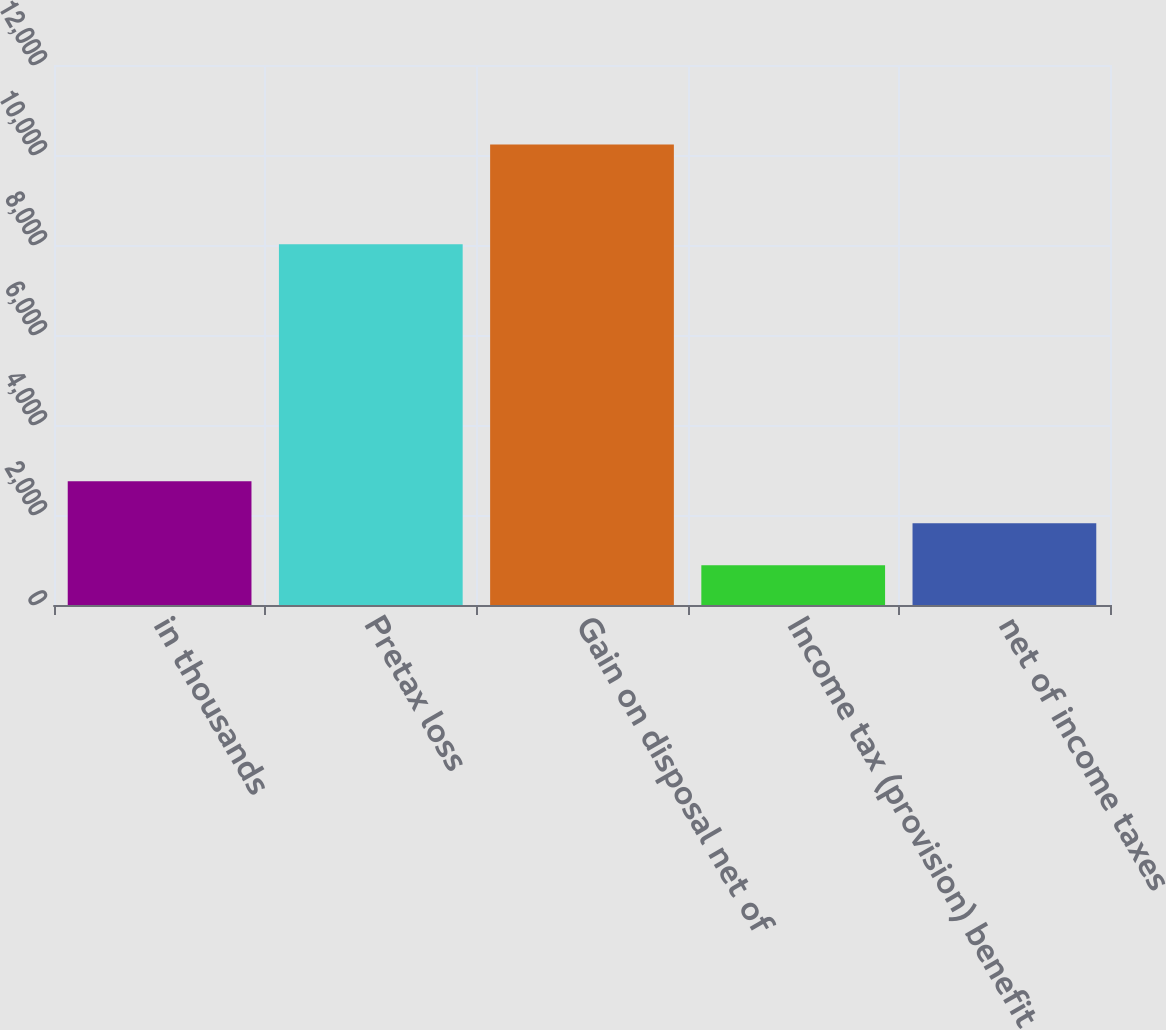Convert chart to OTSL. <chart><loc_0><loc_0><loc_500><loc_500><bar_chart><fcel>in thousands<fcel>Pretax loss<fcel>Gain on disposal net of<fcel>Income tax (provision) benefit<fcel>net of income taxes<nl><fcel>2752<fcel>8017<fcel>10232<fcel>882<fcel>1817<nl></chart> 